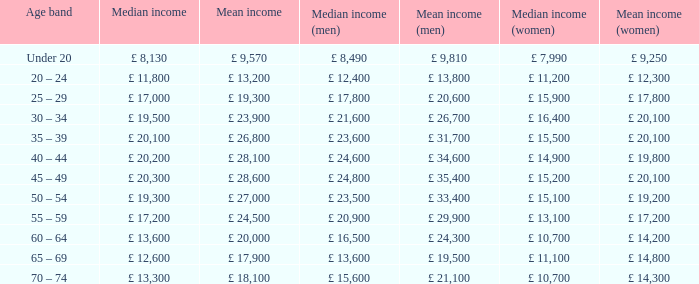Name the median income for age band being under 20 £ 8,130. 